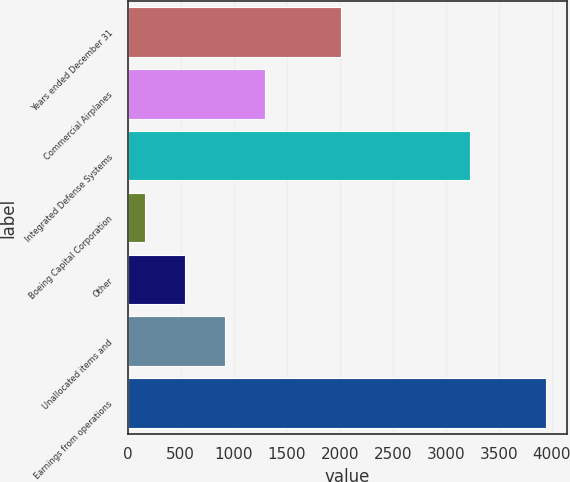Convert chart to OTSL. <chart><loc_0><loc_0><loc_500><loc_500><bar_chart><fcel>Years ended December 31<fcel>Commercial Airplanes<fcel>Integrated Defense Systems<fcel>Boeing Capital Corporation<fcel>Other<fcel>Unallocated items and<fcel>Earnings from operations<nl><fcel>2008<fcel>1298.4<fcel>3232<fcel>162<fcel>540.8<fcel>919.6<fcel>3950<nl></chart> 